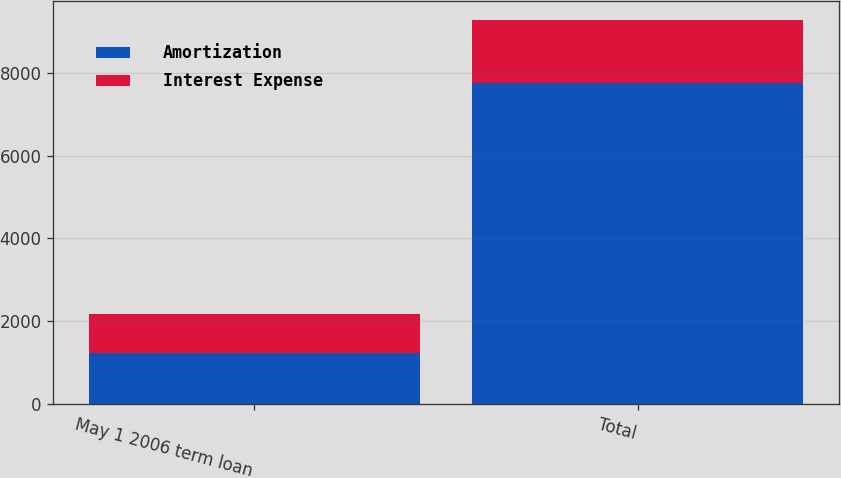<chart> <loc_0><loc_0><loc_500><loc_500><stacked_bar_chart><ecel><fcel>May 1 2006 term loan<fcel>Total<nl><fcel>Amortization<fcel>1219<fcel>7743<nl><fcel>Interest Expense<fcel>952<fcel>1525<nl></chart> 